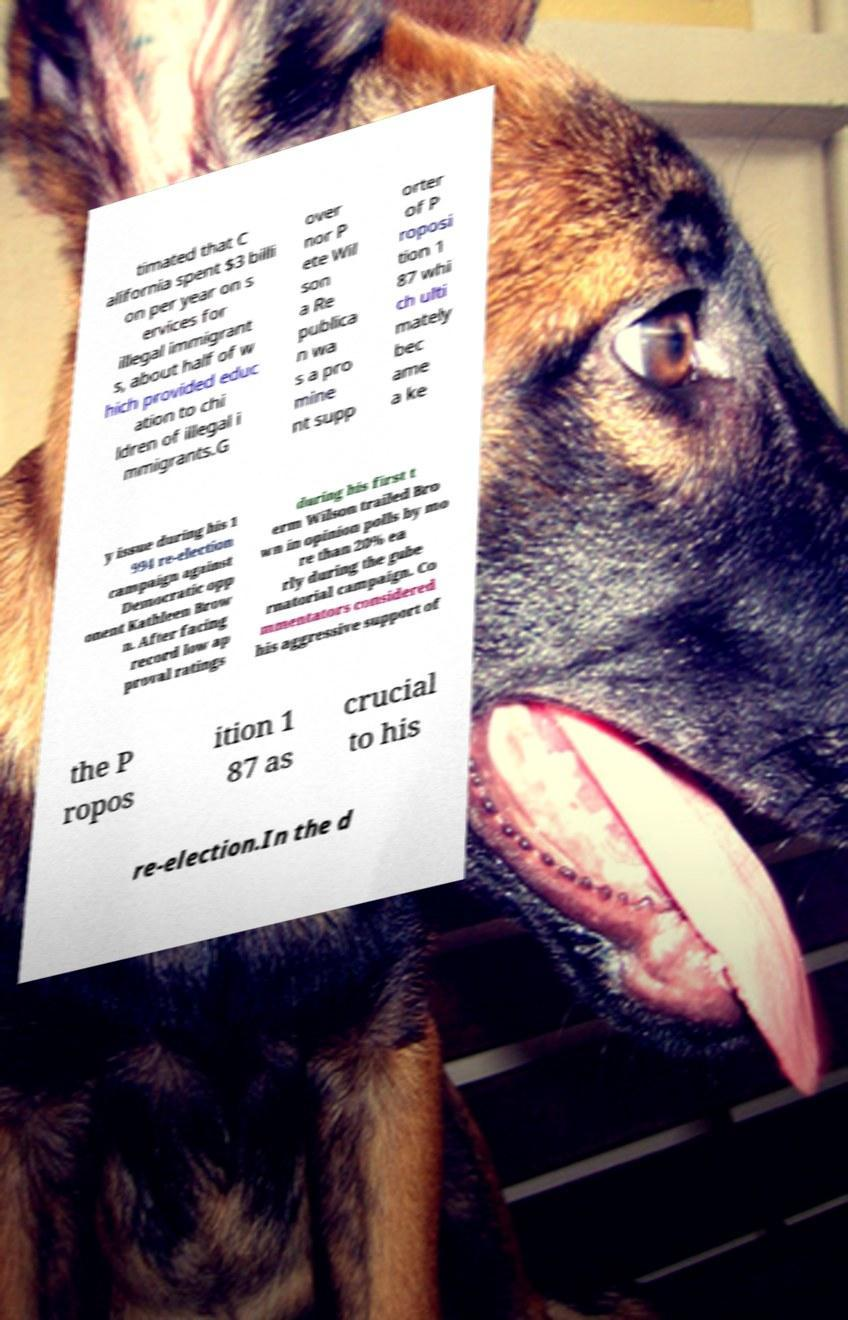Can you read and provide the text displayed in the image?This photo seems to have some interesting text. Can you extract and type it out for me? timated that C alifornia spent $3 billi on per year on s ervices for illegal immigrant s, about half of w hich provided educ ation to chi ldren of illegal i mmigrants.G over nor P ete Wil son a Re publica n wa s a pro mine nt supp orter of P roposi tion 1 87 whi ch ulti mately bec ame a ke y issue during his 1 994 re-election campaign against Democratic opp onent Kathleen Brow n. After facing record low ap proval ratings during his first t erm Wilson trailed Bro wn in opinion polls by mo re than 20% ea rly during the gube rnatorial campaign. Co mmentators considered his aggressive support of the P ropos ition 1 87 as crucial to his re-election.In the d 